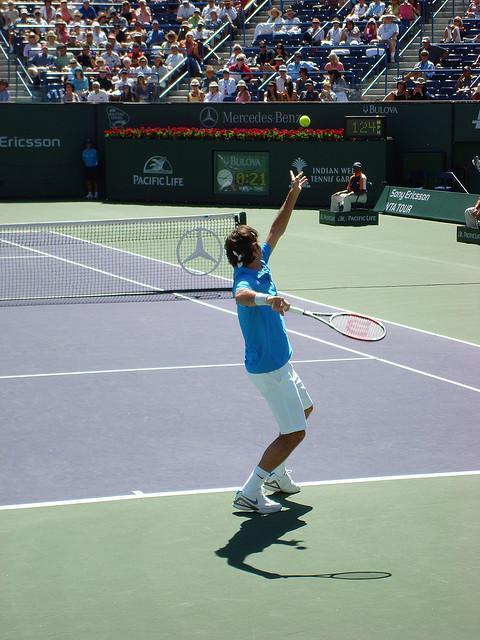How many people are in the picture?
Give a very brief answer. 2. 